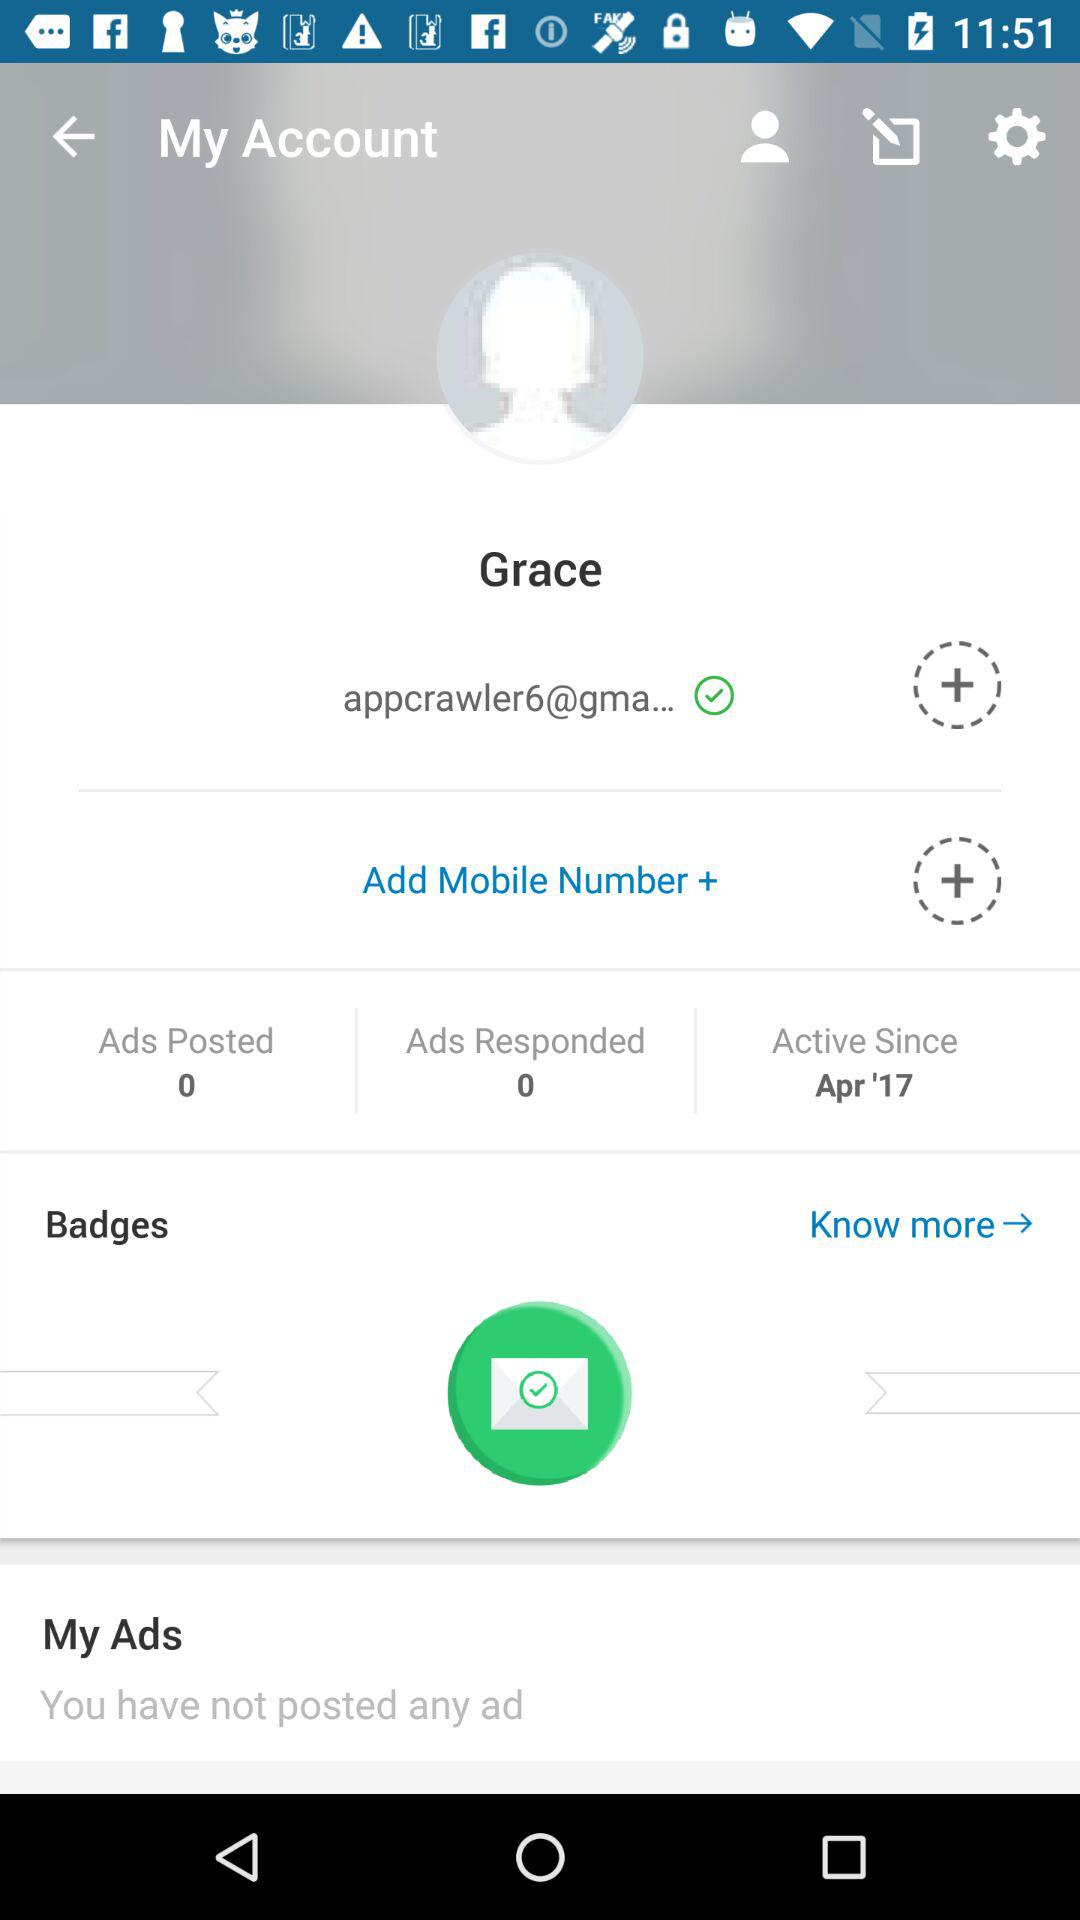What's the user profile name? The user profile name is Grace. 